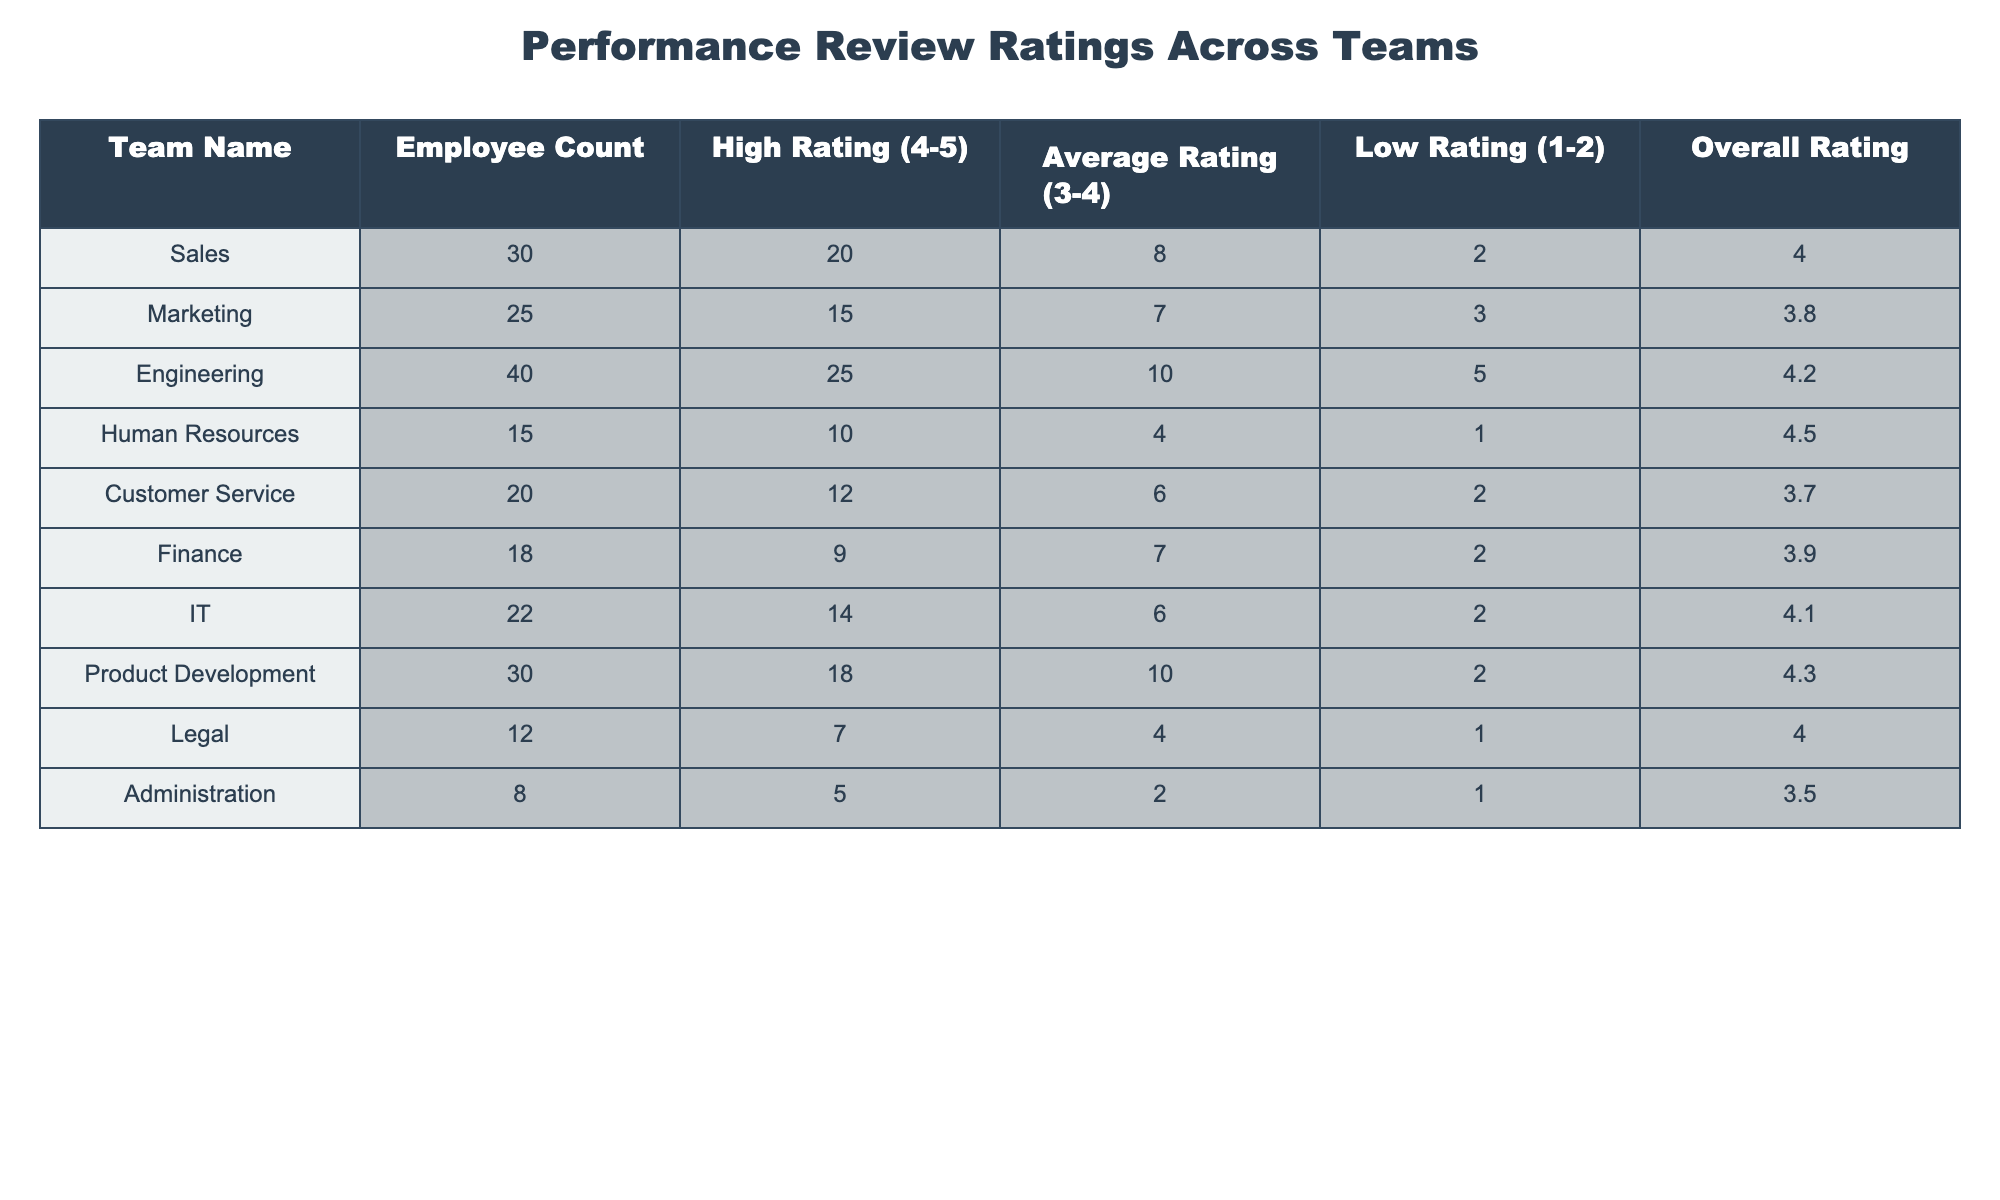What is the overall rating of the Human Resources team? The table shows that the Human Resources team's overall rating is listed in the column labeled "Overall Rating." Referring to that specific data point, the overall rating is 4.5.
Answer: 4.5 Which team has the highest employee count? By examining the "Employee Count" column, we see that Engineering has the highest number of employees at 40.
Answer: Engineering What is the total number of employees across all teams? To find the total employee count, we add the numbers from the "Employee Count" column: 30 + 25 + 40 + 15 + 20 + 18 + 22 + 30 + 12 + 8 =  300.
Answer: 300 Which team has the lowest average rating? The average ratings can be found in the "Average Rating" column. By comparing all values, we find that Administration has the lowest average rating at 3.5.
Answer: Administration Is the majority of the Engineering team receiving a high rating? "High Rating" indicates how many employees received a score of 4 or 5. The Engineering team has 25 high ratings out of 40 employees, which is more than half. Therefore, yes, the majority are receiving high ratings.
Answer: Yes What is the average number of low ratings (1-2) across all teams? To calculate the average low ratings, sum the counts in the "Low Rating" column (2 + 3 + 5 + 1 + 2 + 2 + 2 + 2 + 1 + 1 = 21) and divide by the number of teams (10). So, 21 / 10 = 2.1.
Answer: 2.1 Which team has the highest percentage of high ratings relative to its employee count? To find this, calculate (High Rating / Employee Count) for each team. High Rating for Engineering is 25 from a count of 40, giving a percentage of 62.5%. For Sales, it's 66.67%. After comparing, Sales has the highest percentage.
Answer: Sales How many teams have an overall rating of 4.0 or higher? By counting the "Overall Rating" values that are 4.0 or above, we see that Human Resources, Engineering, IT, Product Development, and Legal meet this criterion. This totals 5 teams.
Answer: 5 What is the difference in high ratings between the Sales and Marketing teams? Sales has 20 high ratings while Marketing has 15. The difference is 20 - 15 = 5.
Answer: 5 Is the Customer Service team's average rating above the overall average of all teams? The overall average rating needs to be calculated first (sum all ratings: (4.0 + 3.8 + 4.2 + 4.5 + 3.7 + 3.9 + 4.1 + 4.3 + 4.0 + 3.5) = 41.0 / 10 = 4.1). Customer Service has an average of 3.7, which is below 4.1.
Answer: No 